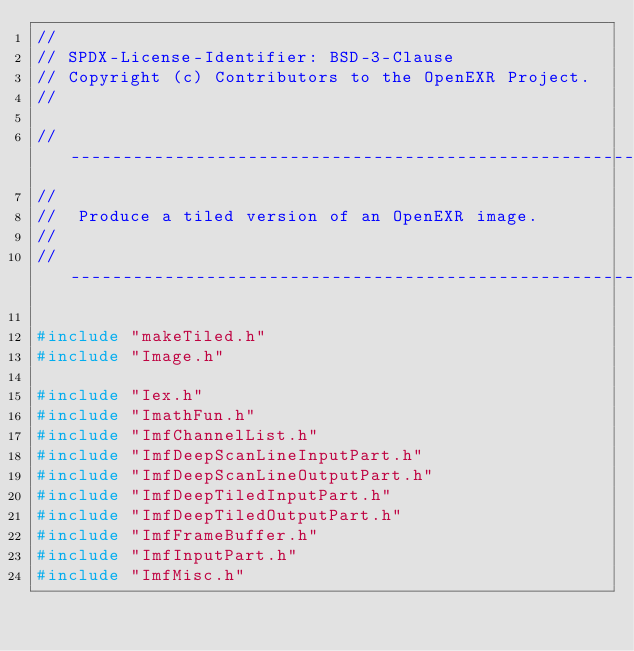<code> <loc_0><loc_0><loc_500><loc_500><_C++_>//
// SPDX-License-Identifier: BSD-3-Clause
// Copyright (c) Contributors to the OpenEXR Project.
//

//----------------------------------------------------------------------------
//
//	Produce a tiled version of an OpenEXR image.
//
//----------------------------------------------------------------------------

#include "makeTiled.h"
#include "Image.h"

#include "Iex.h"
#include "ImathFun.h"
#include "ImfChannelList.h"
#include "ImfDeepScanLineInputPart.h"
#include "ImfDeepScanLineOutputPart.h"
#include "ImfDeepTiledInputPart.h"
#include "ImfDeepTiledOutputPart.h"
#include "ImfFrameBuffer.h"
#include "ImfInputPart.h"
#include "ImfMisc.h"</code> 